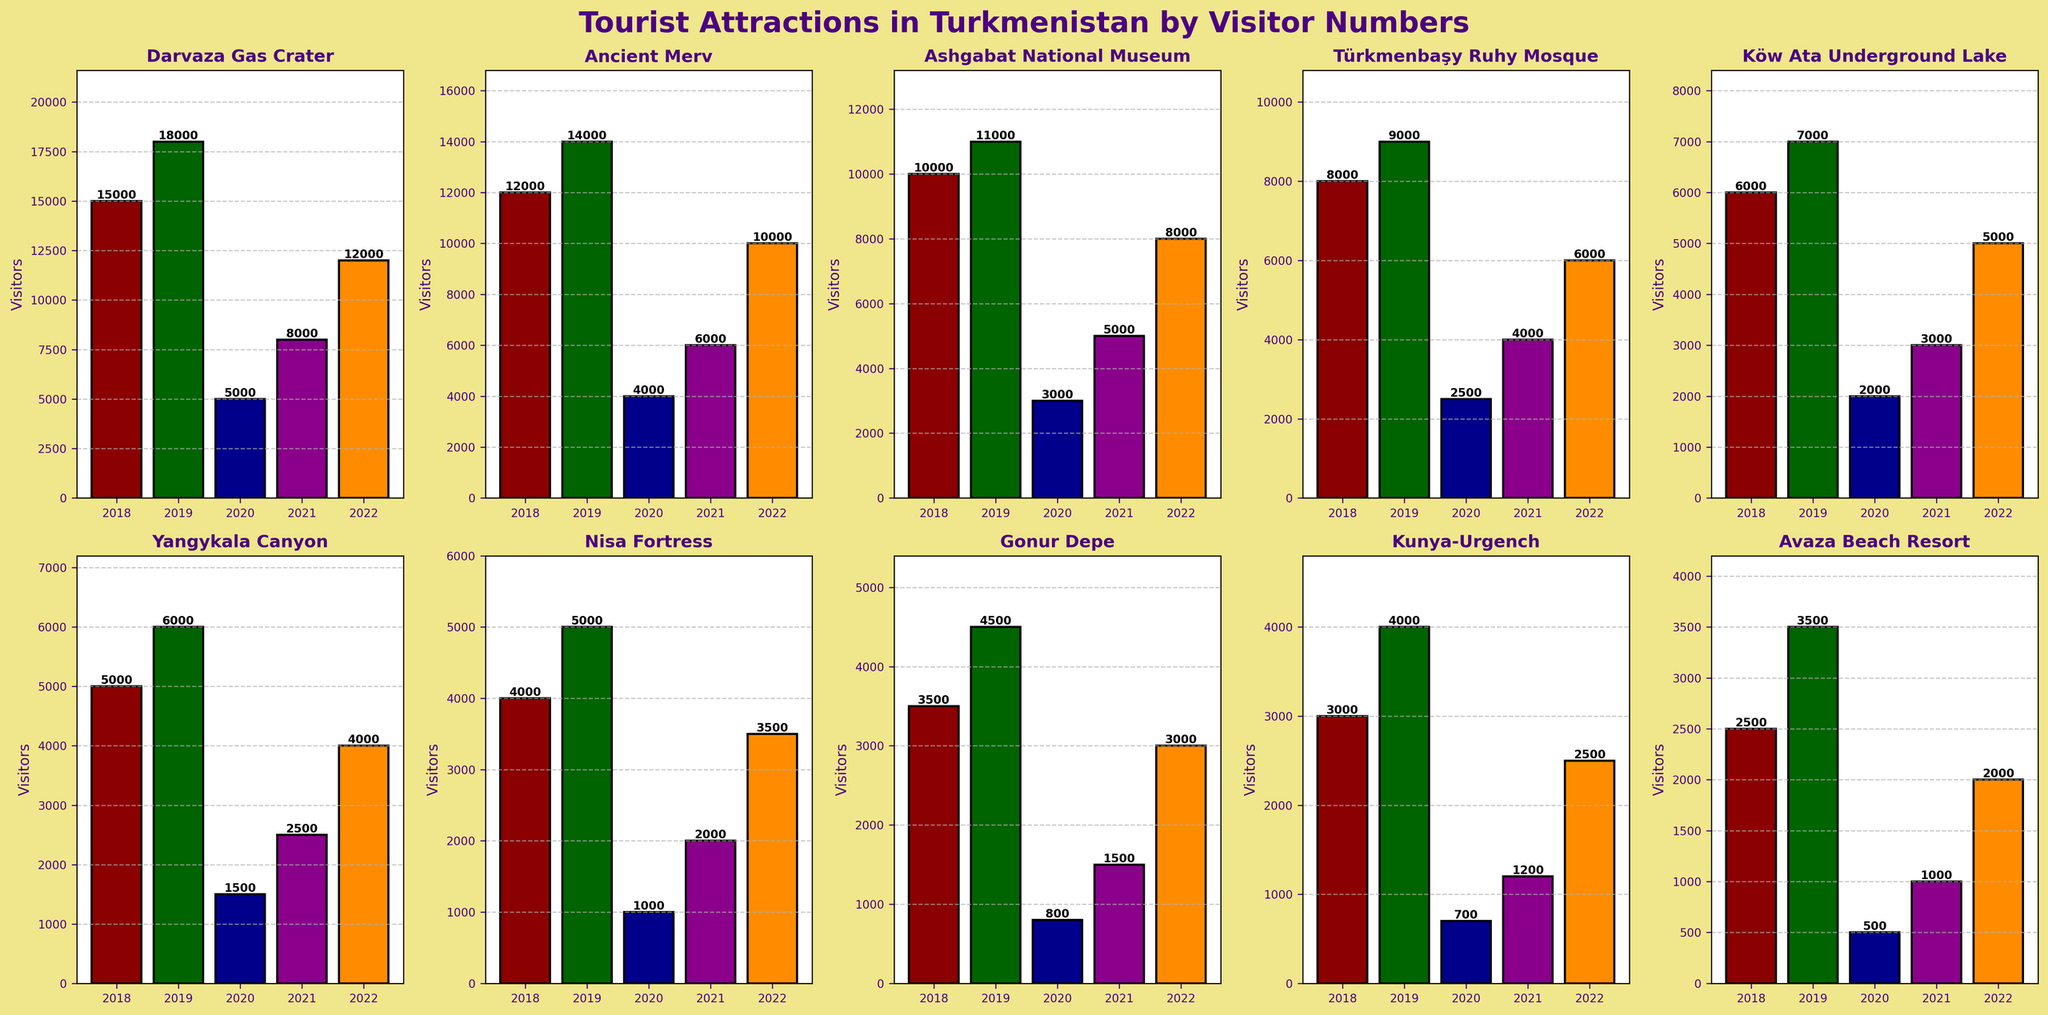What was the total number of visitors to the Darvaza Gas Crater from 2018 to 2022? To find the total number of visitors to the Darvaza Gas Crater from 2018 to 2022, sum the visitor counts for each year: 15000 + 18000 + 5000 + 8000 + 12000 = 58000
Answer: 58000 Which attraction had the highest number of visitors in 2022? To determine the attraction with the highest number of visitors in 2022, compare the visitor numbers for each attraction in 2022. Darvaza Gas Crater had 12000 visitors, which is the highest among the attractions listed.
Answer: Darvaza Gas Crater How did the visitor numbers at the Ashgabat National Museum change between 2018 and 2020? To understand the change in visitor numbers, look at the count for 2018 and 2020: 2018 had 10000 visitors and 2020 had 3000 visitors. The change is 3000 - 10000 = -7000.
Answer: Decreased by 7000 Which year had the lowest number of visitors for Yangykala Canyon? Check the visitor number each year: 2018 had 5000, 2019 had 6000, 2020 had 1500, 2021 had 2500, and 2022 had 4000. The lowest count is 1500 in the year 2020.
Answer: 2020 Compare the visitor numbers for Türkmenbaşy Ruhy Mosque and Köw Ata Underground Lake in 2021. Which one had more visitors? Türkmenbaşy Ruhy Mosque had 4000 visitors in 2021, while Köw Ata Underground Lake had 3000. By comparing these, Türkmenbaşy Ruhy Mosque had more visitors.
Answer: Türkmenbaşy Ruhy Mosque What was the average number of visitors to the Ancient Merv per year from 2018 to 2022? To find the average number of visitors per year, sum the visitor numbers for Ancient Merv and divide by the number of years: (12000 + 14000 + 4000 + 6000 + 10000) / 5 = 9200.
Answer: 9200 Which attraction had the least number of visitors in any single year, and what was that number? The lowest number of visitors overall is 500 visitors to Avaza Beach Resort in 2020.
Answer: Avaza Beach Resort, 500 How did the number of visitors to the Nisa Fortress change from 2020 to 2022? In 2020, Nisa Fortress had 1000 visitors, and in 2022 it had 3500 visitors. The change is 3500 - 1000 = 2500.
Answer: Increased by 2500 Which attraction showed the most consistent number of visitors from 2018 to 2022? Köw Ata Underground Lake had visitor numbers of 6000, 7000, 2000, 3000, and 5000, respectively. The range of variation is less compared to other attractions with more volatile numbers, indicating more consistency.
Answer: Köw Ata Underground Lake 